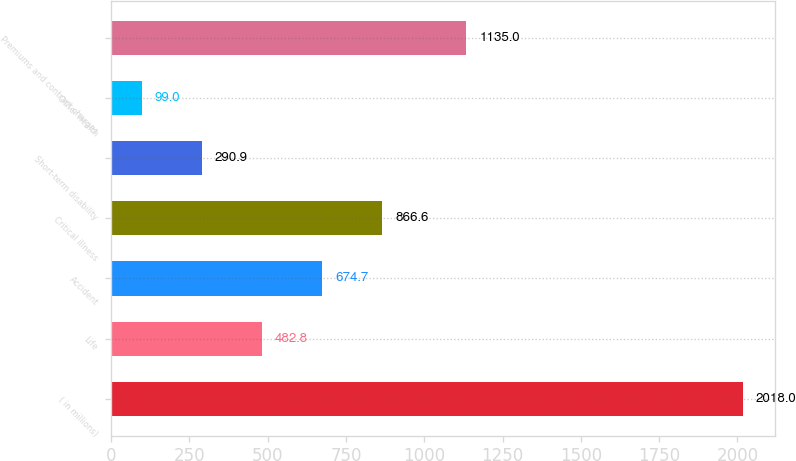Convert chart. <chart><loc_0><loc_0><loc_500><loc_500><bar_chart><fcel>( in millions)<fcel>Life<fcel>Accident<fcel>Critical illness<fcel>Short-term disability<fcel>Other health<fcel>Premiums and contract charges<nl><fcel>2018<fcel>482.8<fcel>674.7<fcel>866.6<fcel>290.9<fcel>99<fcel>1135<nl></chart> 